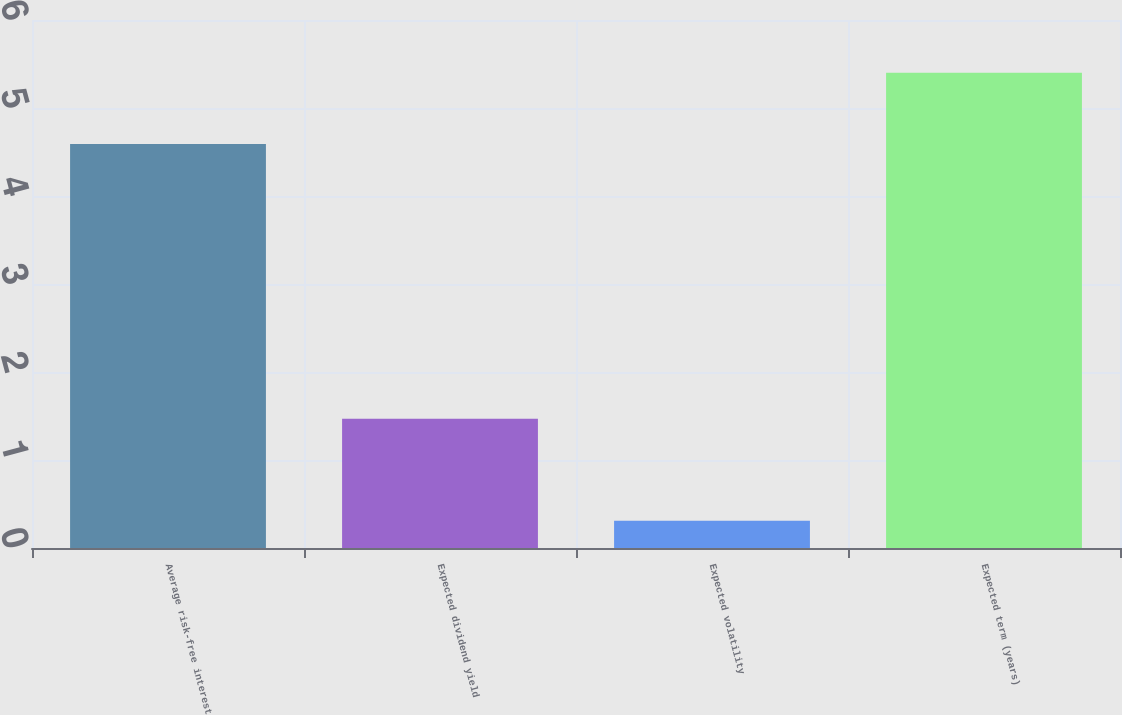<chart> <loc_0><loc_0><loc_500><loc_500><bar_chart><fcel>Average risk-free interest<fcel>Expected dividend yield<fcel>Expected volatility<fcel>Expected term (years)<nl><fcel>4.59<fcel>1.47<fcel>0.31<fcel>5.4<nl></chart> 